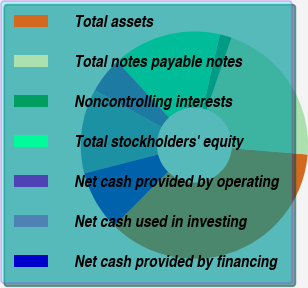Convert chart to OTSL. <chart><loc_0><loc_0><loc_500><loc_500><pie_chart><fcel>Total assets<fcel>Total notes payable notes<fcel>Noncontrolling interests<fcel>Total stockholders' equity<fcel>Net cash provided by operating<fcel>Net cash used in investing<fcel>Net cash provided by financing<nl><fcel>36.11%<fcel>21.03%<fcel>1.69%<fcel>15.46%<fcel>5.13%<fcel>12.01%<fcel>8.57%<nl></chart> 